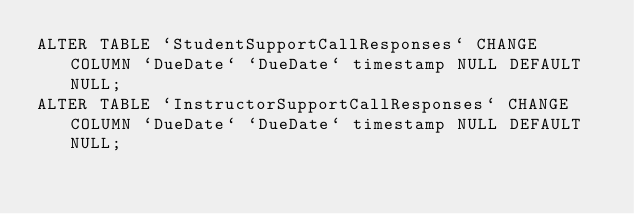<code> <loc_0><loc_0><loc_500><loc_500><_SQL_>ALTER TABLE `StudentSupportCallResponses` CHANGE COLUMN `DueDate` `DueDate` timestamp NULL DEFAULT NULL;
ALTER TABLE `InstructorSupportCallResponses` CHANGE COLUMN `DueDate` `DueDate` timestamp NULL DEFAULT NULL;</code> 